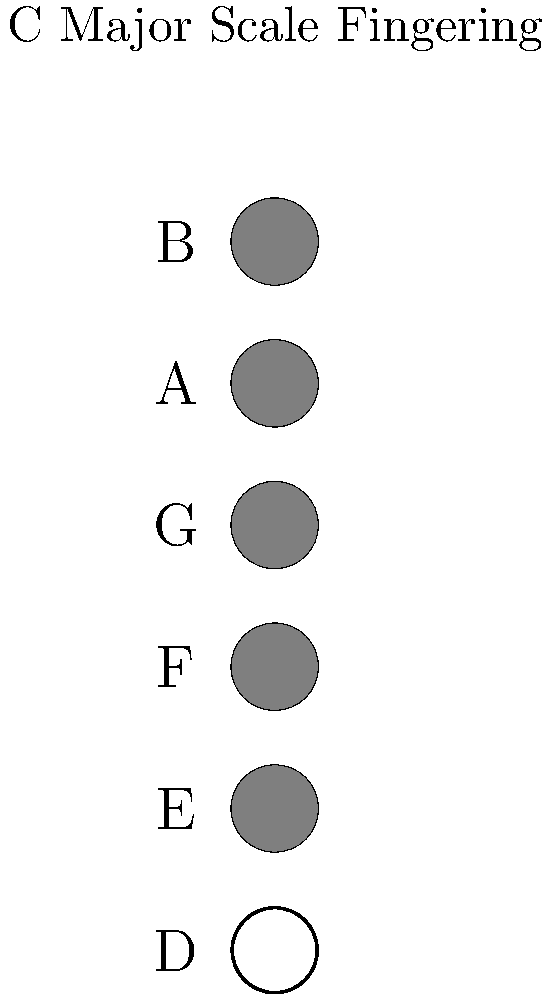Based on the saxophone fingering chart shown for the C major scale, which note would be produced if a player were to lift their finger from the A key while maintaining the fingering for all other keys? To answer this question, let's break down the fingering chart and understand its implications:

1. The chart shows the fingering for a C major scale on a saxophone.
2. Each circle represents a key, with filled circles indicating pressed keys.
3. The keys are labeled from top to bottom as B, A, G, F, E, and D.
4. In the given fingering, all keys from B to E are pressed (filled), while D is open.
5. This fingering produces the note C, which is the root of the C major scale.

Now, let's consider what happens when we lift the finger from the A key:

6. Lifting a finger from a pressed key creates a higher pitch.
7. The next note in the C major scale above C is D.
8. To produce D, we typically lift the finger from the A key while keeping the other fingers in place.

Therefore, by lifting the finger from the A key while maintaining the fingering for all other keys, the saxophone would produce the note D, which is the second note in the C major scale.
Answer: D 